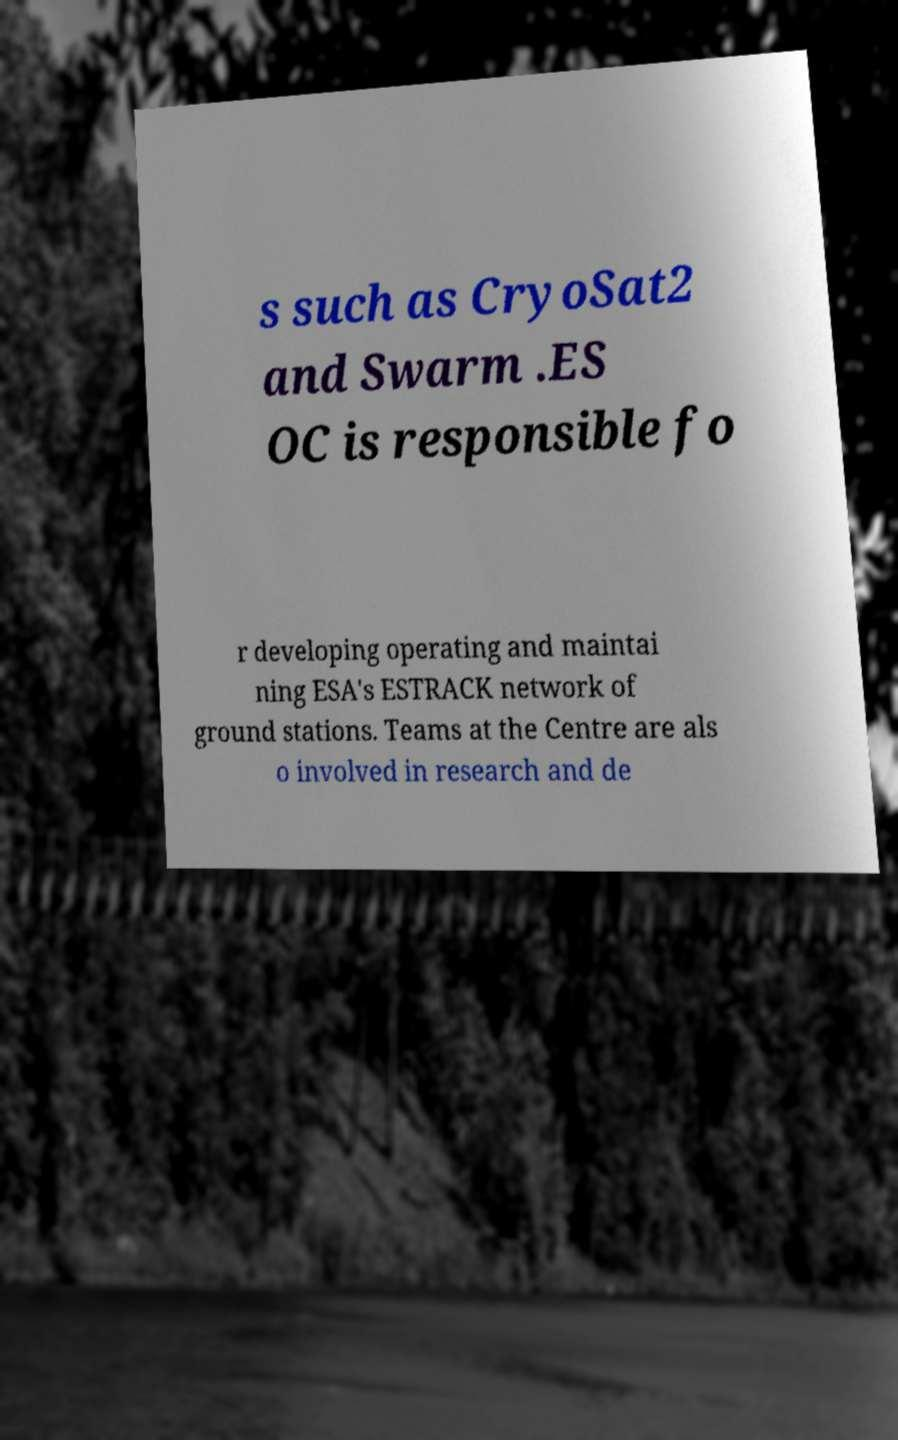Can you read and provide the text displayed in the image?This photo seems to have some interesting text. Can you extract and type it out for me? s such as CryoSat2 and Swarm .ES OC is responsible fo r developing operating and maintai ning ESA's ESTRACK network of ground stations. Teams at the Centre are als o involved in research and de 